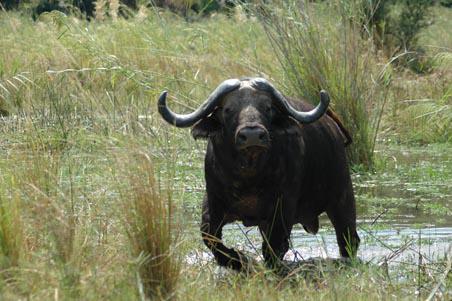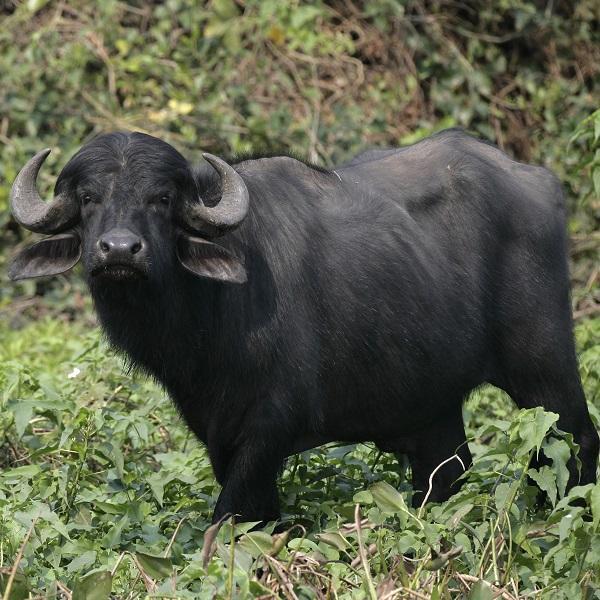The first image is the image on the left, the second image is the image on the right. Considering the images on both sides, is "At least one image shows a buffalo in the water." valid? Answer yes or no. Yes. The first image is the image on the left, the second image is the image on the right. For the images displayed, is the sentence "In one of the image a water buffalo is standing in the water." factually correct? Answer yes or no. Yes. 